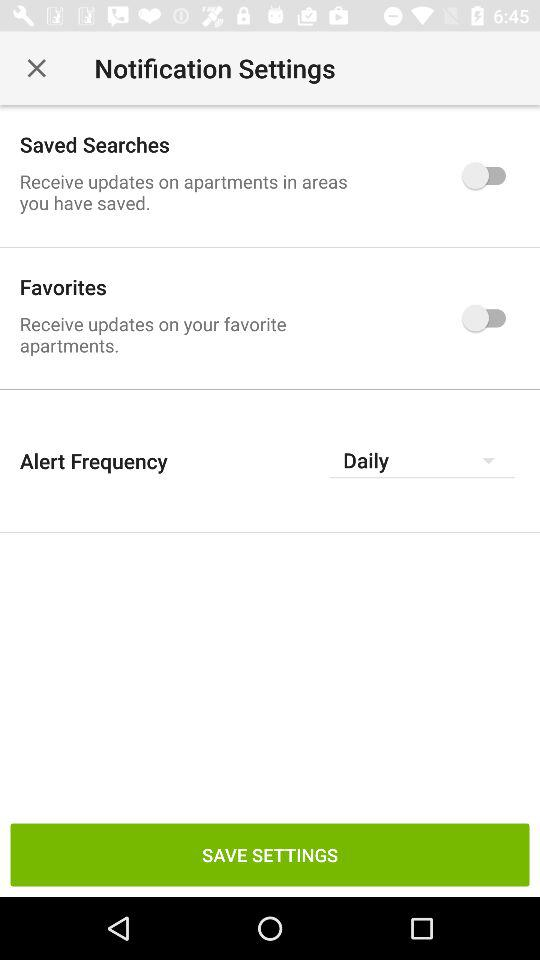What is the status of "Favorites"? The status of "Favorites" is "off". 